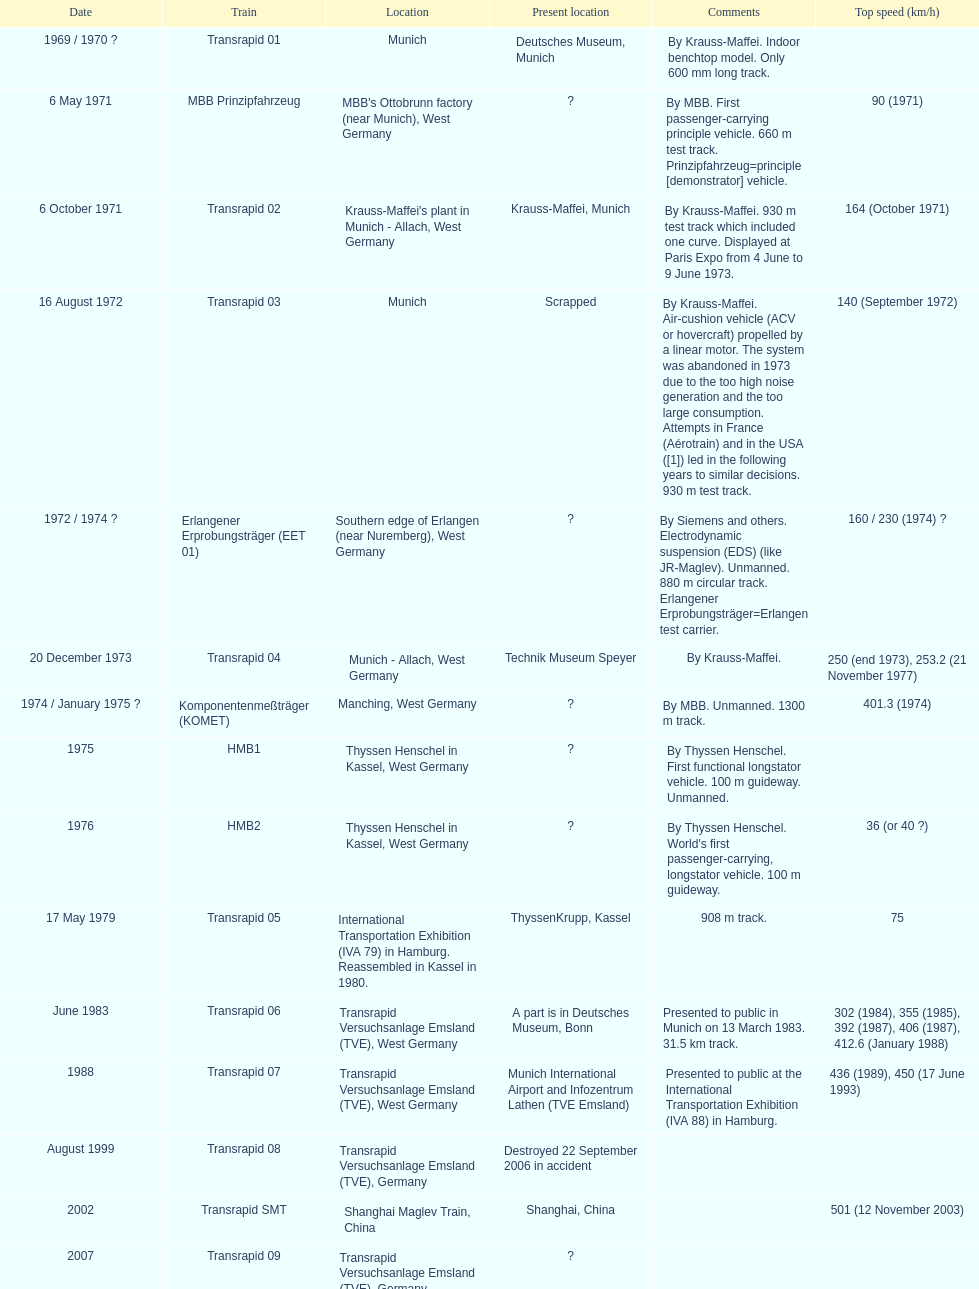Could you help me parse every detail presented in this table? {'header': ['Date', 'Train', 'Location', 'Present location', 'Comments', 'Top speed (km/h)'], 'rows': [['1969 / 1970\xa0?', 'Transrapid 01', 'Munich', 'Deutsches Museum, Munich', 'By Krauss-Maffei. Indoor benchtop model. Only 600\xa0mm long track.', ''], ['6 May 1971', 'MBB Prinzipfahrzeug', "MBB's Ottobrunn factory (near Munich), West Germany", '?', 'By MBB. First passenger-carrying principle vehicle. 660 m test track. Prinzipfahrzeug=principle [demonstrator] vehicle.', '90 (1971)'], ['6 October 1971', 'Transrapid 02', "Krauss-Maffei's plant in Munich - Allach, West Germany", 'Krauss-Maffei, Munich', 'By Krauss-Maffei. 930 m test track which included one curve. Displayed at Paris Expo from 4 June to 9 June 1973.', '164 (October 1971)'], ['16 August 1972', 'Transrapid 03', 'Munich', 'Scrapped', 'By Krauss-Maffei. Air-cushion vehicle (ACV or hovercraft) propelled by a linear motor. The system was abandoned in 1973 due to the too high noise generation and the too large consumption. Attempts in France (Aérotrain) and in the USA ([1]) led in the following years to similar decisions. 930 m test track.', '140 (September 1972)'], ['1972 / 1974\xa0?', 'Erlangener Erprobungsträger (EET 01)', 'Southern edge of Erlangen (near Nuremberg), West Germany', '?', 'By Siemens and others. Electrodynamic suspension (EDS) (like JR-Maglev). Unmanned. 880 m circular track. Erlangener Erprobungsträger=Erlangen test carrier.', '160 / 230 (1974)\xa0?'], ['20 December 1973', 'Transrapid 04', 'Munich - Allach, West Germany', 'Technik Museum Speyer', 'By Krauss-Maffei.', '250 (end 1973), 253.2 (21 November 1977)'], ['1974 / January 1975\xa0?', 'Komponentenmeßträger (KOMET)', 'Manching, West Germany', '?', 'By MBB. Unmanned. 1300 m track.', '401.3 (1974)'], ['1975', 'HMB1', 'Thyssen Henschel in Kassel, West Germany', '?', 'By Thyssen Henschel. First functional longstator vehicle. 100 m guideway. Unmanned.', ''], ['1976', 'HMB2', 'Thyssen Henschel in Kassel, West Germany', '?', "By Thyssen Henschel. World's first passenger-carrying, longstator vehicle. 100 m guideway.", '36 (or 40\xa0?)'], ['17 May 1979', 'Transrapid 05', 'International Transportation Exhibition (IVA 79) in Hamburg. Reassembled in Kassel in 1980.', 'ThyssenKrupp, Kassel', '908 m track.', '75'], ['June 1983', 'Transrapid 06', 'Transrapid Versuchsanlage Emsland (TVE), West Germany', 'A part is in Deutsches Museum, Bonn', 'Presented to public in Munich on 13 March 1983. 31.5\xa0km track.', '302 (1984), 355 (1985), 392 (1987), 406 (1987), 412.6 (January 1988)'], ['1988', 'Transrapid 07', 'Transrapid Versuchsanlage Emsland (TVE), West Germany', 'Munich International Airport and Infozentrum Lathen (TVE Emsland)', 'Presented to public at the International Transportation Exhibition (IVA 88) in Hamburg.', '436 (1989), 450 (17 June 1993)'], ['August 1999', 'Transrapid 08', 'Transrapid Versuchsanlage Emsland (TVE), Germany', 'Destroyed 22 September 2006 in accident', '', ''], ['2002', 'Transrapid SMT', 'Shanghai Maglev Train, China', 'Shanghai, China', '', '501 (12 November 2003)'], ['2007', 'Transrapid 09', 'Transrapid Versuchsanlage Emsland (TVE), Germany', '?', '', '']]} How many trains other than the transrapid 07 can go faster than 450km/h? 1. 